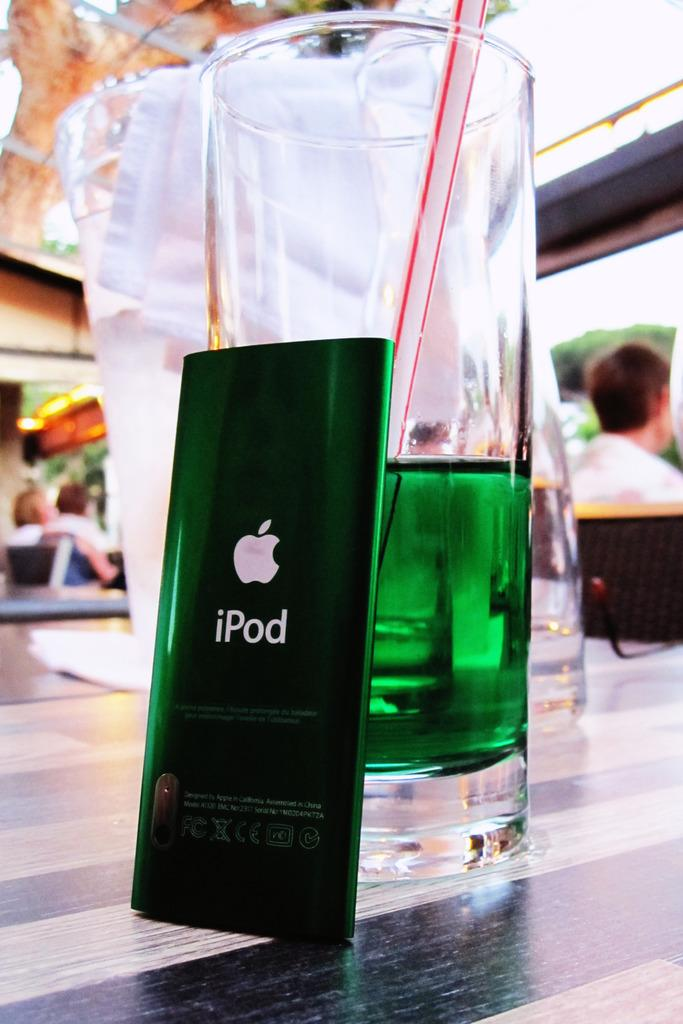<image>
Relay a brief, clear account of the picture shown. A green iPod is resting on glass full of green liquid. 